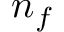Convert formula to latex. <formula><loc_0><loc_0><loc_500><loc_500>n _ { f }</formula> 